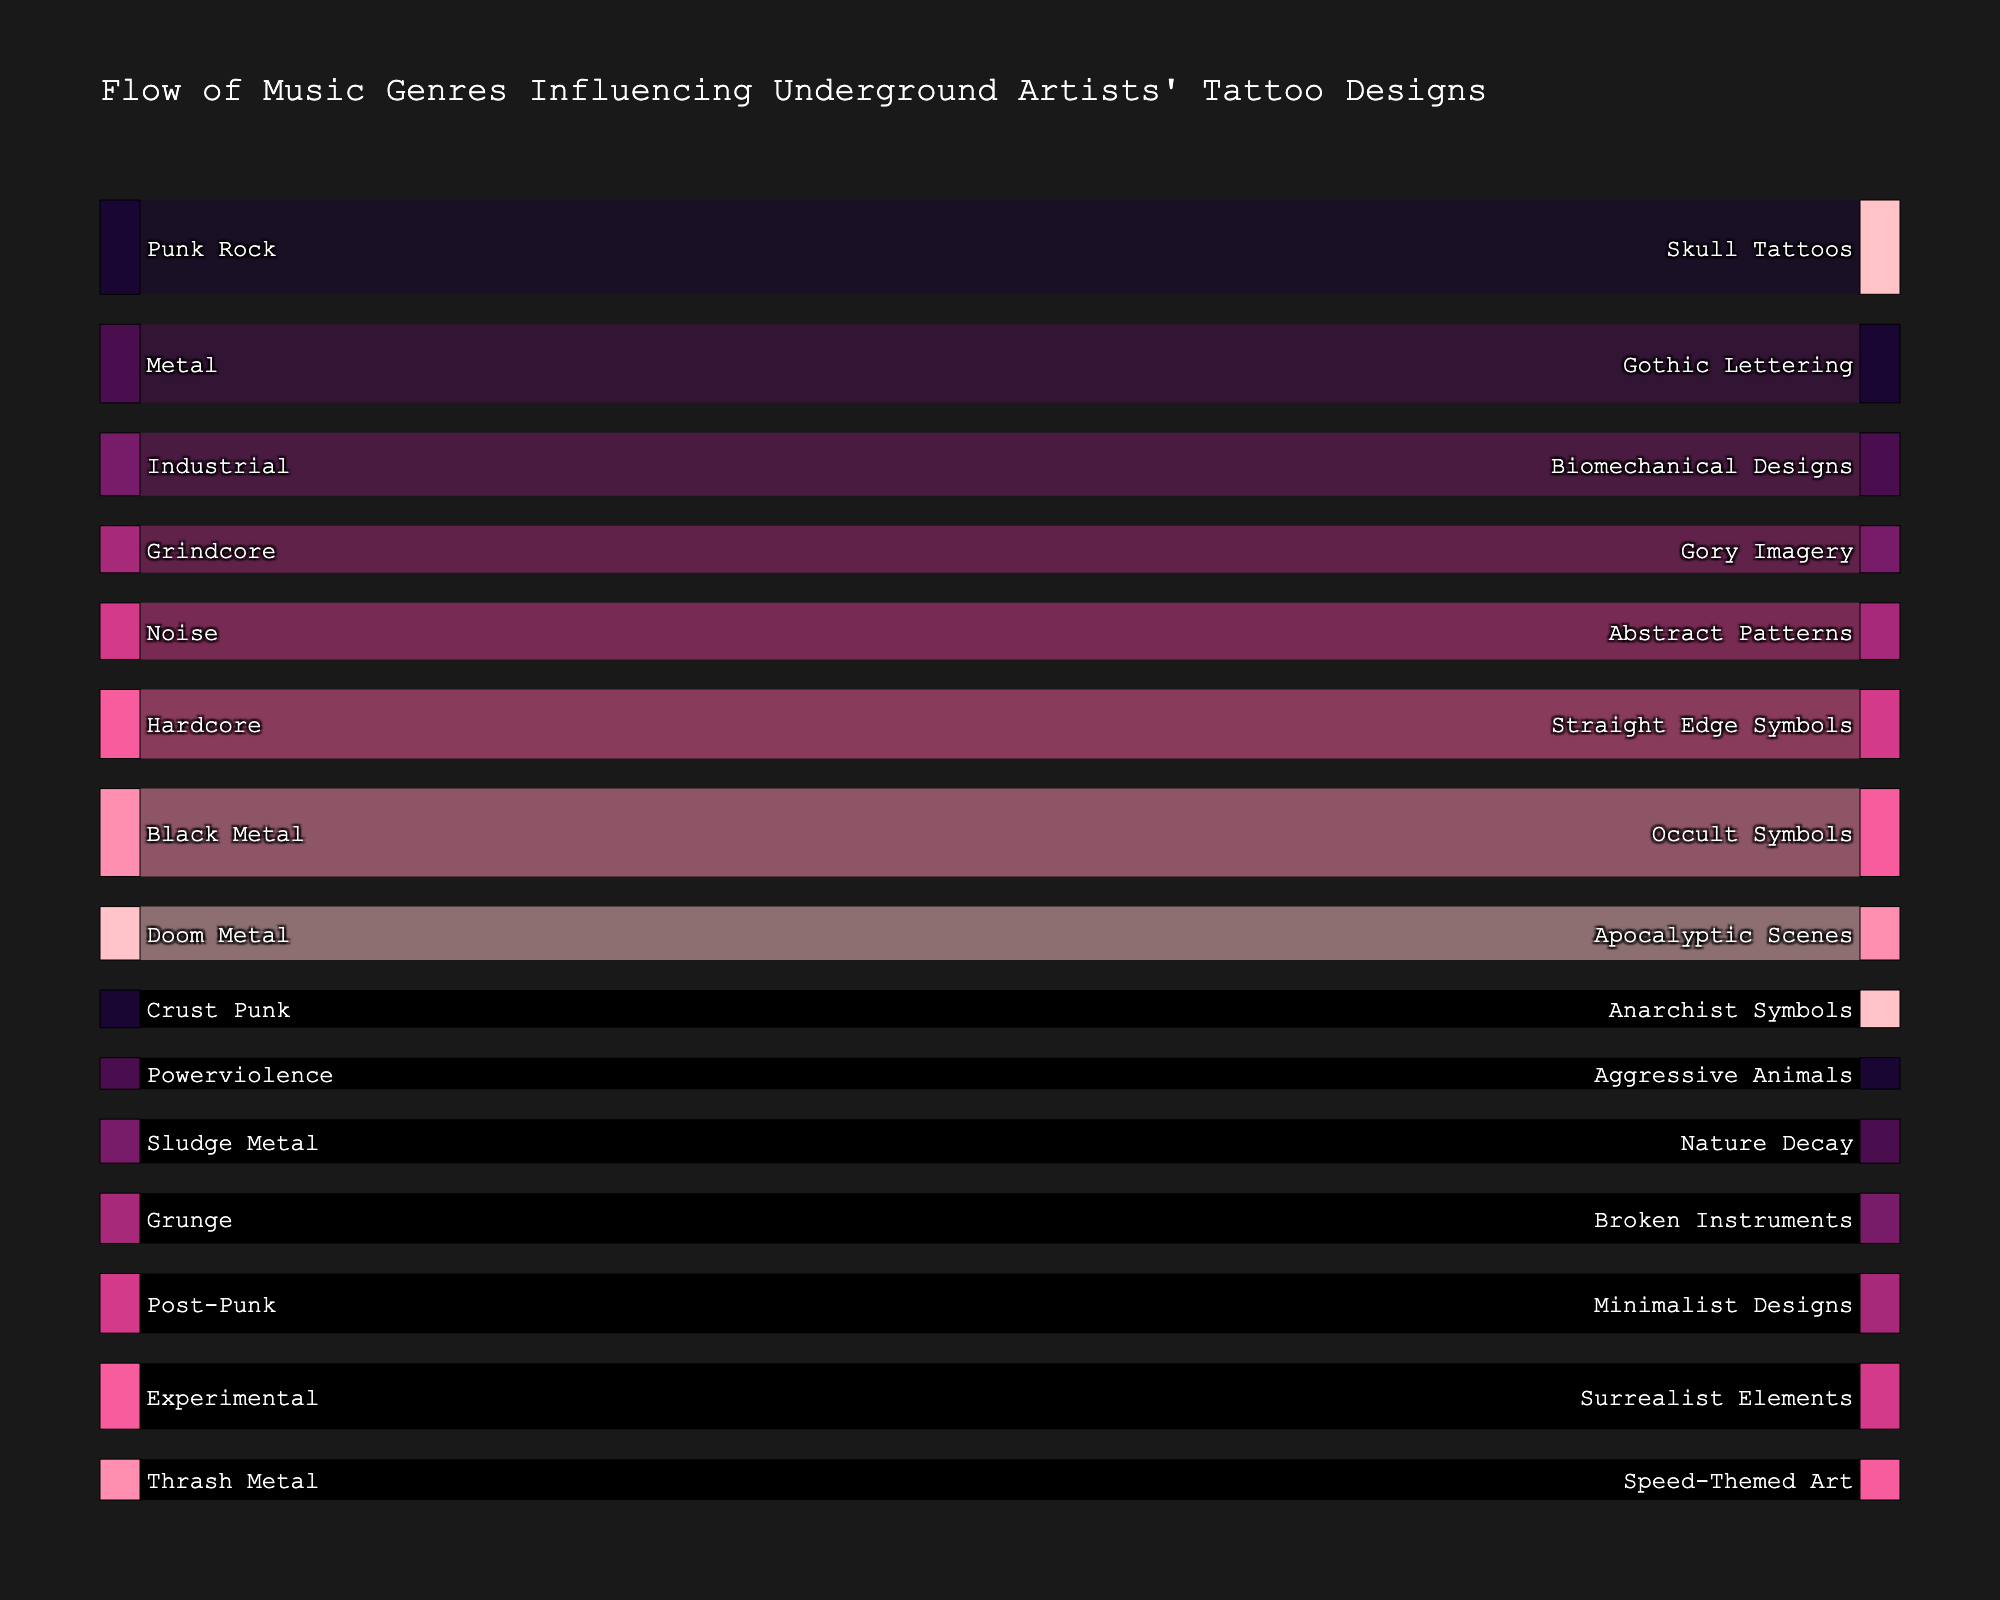Which music genre has the highest influence on skull tattoos? To determine this, look for the arrow leading to "Skull Tattoos" and identify the originating genre. The thickness of the flow represents the value, which you can deduce from the label.
Answer: Punk Rock What is the total number of tattoos influenced by Industrial and Metal genres combined? Find the values associated with Industrial and Metal in the figure (Industrial to Biomechanical Designs and Metal to Gothic Lettering) and add them together: 20 (Industrial) + 25 (Metal) = 45.
Answer: 45 Which tattoo design has the fewest influences from any genre? Locate the tattoo design with the thinnest inflow arrow. By comparing the flows, "Aggressive Animals" has the smallest value.
Answer: Aggressive Animals How much more influence does Punk Rock have on Skull Tattoos compared to Grindcore's influence on Gory Imagery? Identify the values for both Punk Rock to Skull Tattoos (30) and Grindcore to Gory Imagery (15). Subtract the latter from the former: 30 - 15 = 15.
Answer: 15 Which genre influences Minimalist Designs? Find the arrow leading to "Minimalist Designs" and trace it back to its source genre.
Answer: Post-Punk What is the total influence of genres on tattoo designs featuring occult symbols and apocalyptic scenes? Look at the values for both "Occult Symbols" and "Apocalyptic Scenes" influenced by Black Metal and Doom Metal, respectively. Sum those values: 28 (Black Metal) + 17 (Doom Metal) = 45.
Answer: 45 Which genre has more influence on tattoo designs: Sludge Metal or Hardcore? Compare the values from Sludge Metal (14) and Hardcore (22). Hardcore has a greater value.
Answer: Hardcore What's the most frequent tattoo design influenced by the genres shown? To determine this, identify the tattoo design that appears with the highest number of incoming connections. Each design has one unique genre connection, so this question reverts to the design influenced by the genre with the highest value—Skull Tattoos (30).
Answer: Skull Tattoos Which tattoo design does Grunge influence and how many influences does it have? Locate Grunge and trace the line to its target tattoo design, which is "Broken Instruments". The connected value shows the number of influences (16).
Answer: Broken Instruments, 16 What is the sum of influences on tattoo designs featuring Anarchist Symbols and Nature Decay? Add the values for Crust Punk to Anarchist Symbols (12) and Sludge Metal to Nature Decay (14): 12 + 14 = 26.
Answer: 26 